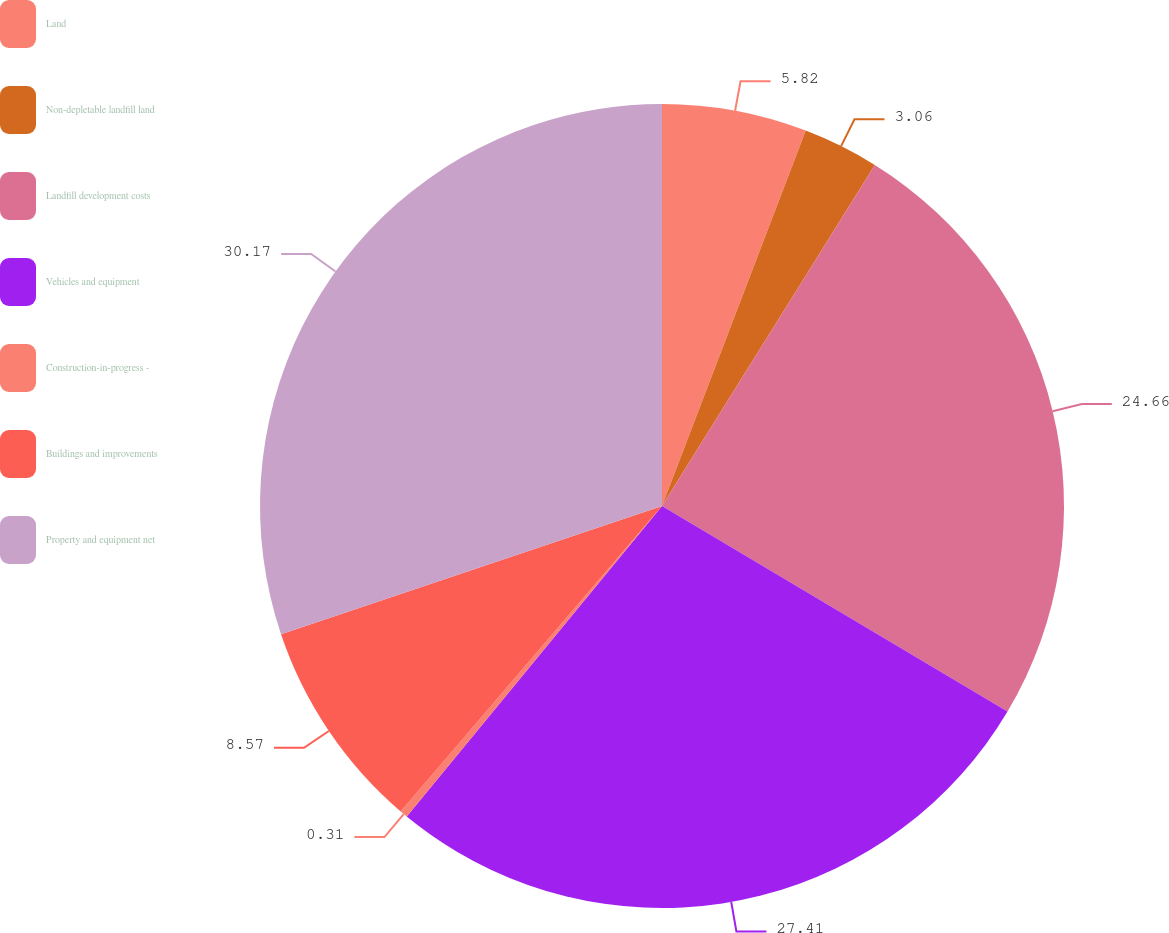Convert chart. <chart><loc_0><loc_0><loc_500><loc_500><pie_chart><fcel>Land<fcel>Non-depletable landfill land<fcel>Landfill development costs<fcel>Vehicles and equipment<fcel>Construction-in-progress -<fcel>Buildings and improvements<fcel>Property and equipment net<nl><fcel>5.82%<fcel>3.06%<fcel>24.66%<fcel>27.41%<fcel>0.31%<fcel>8.57%<fcel>30.17%<nl></chart> 